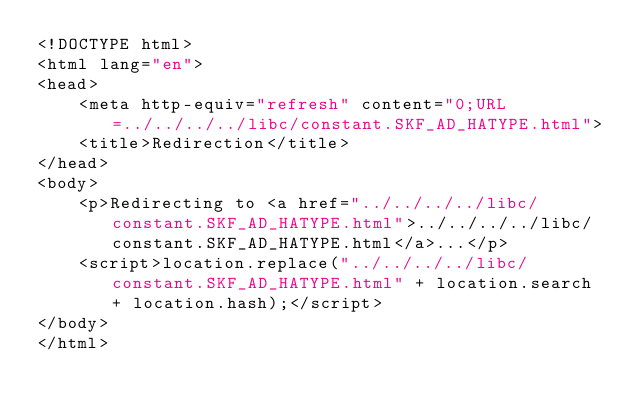Convert code to text. <code><loc_0><loc_0><loc_500><loc_500><_HTML_><!DOCTYPE html>
<html lang="en">
<head>
    <meta http-equiv="refresh" content="0;URL=../../../../libc/constant.SKF_AD_HATYPE.html">
    <title>Redirection</title>
</head>
<body>
    <p>Redirecting to <a href="../../../../libc/constant.SKF_AD_HATYPE.html">../../../../libc/constant.SKF_AD_HATYPE.html</a>...</p>
    <script>location.replace("../../../../libc/constant.SKF_AD_HATYPE.html" + location.search + location.hash);</script>
</body>
</html></code> 